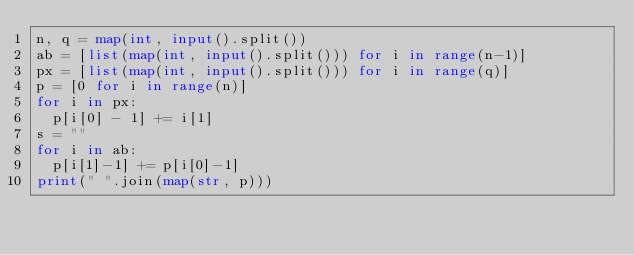Convert code to text. <code><loc_0><loc_0><loc_500><loc_500><_Python_>n, q = map(int, input().split())
ab = [list(map(int, input().split())) for i in range(n-1)]
px = [list(map(int, input().split())) for i in range(q)]
p = [0 for i in range(n)]
for i in px:
  p[i[0] - 1] += i[1]
s = ""
for i in ab:
  p[i[1]-1] += p[i[0]-1]
print(" ".join(map(str, p)))</code> 